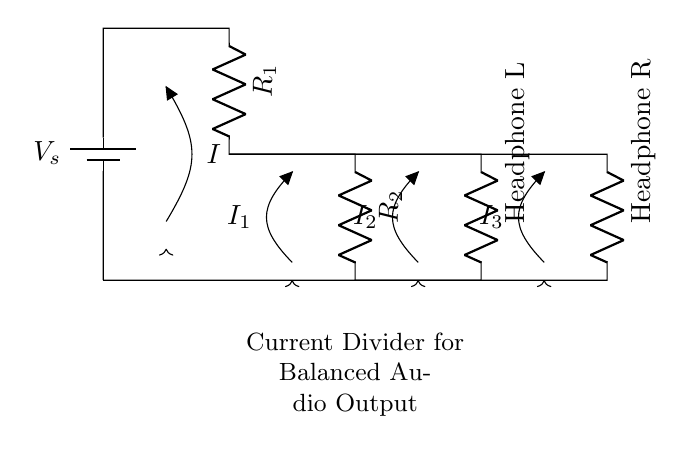What are the resistances in this circuit? The circuit contains two resistors labeled as R1 and R2. The specific values can be inferred from the circuit diagram if indicated, but in this case, they are just presented generically.
Answer: R1, R2 What does the battery represent? The battery symbol labeled V_s represents the voltage source for the circuit, providing the necessary electrical energy to power the audio output.
Answer: V_s What is the purpose of the current divider in this circuit? The current divider is used to split the input current into separate branches, allowing for balanced audio output between the left and right headphones.
Answer: Balanced audio output Which components are connected to the output? The output components are two resistors representing headphones, labeled as Headphone L and Headphone R, connected in parallel to receive the divided current.
Answer: Headphone L, Headphone R How does the total current relate to the branch currents? The total current (I) entering the divider is the sum of the currents through each branch (I1 and I2), thus I equals I1 plus I2 indicating that current is conserved in parallel circuits.
Answer: I = I1 + I2 What would happen if one headphone fails? If one headphone fails (creates an open circuit), the current would only flow through the functioning headphone, resulting in the loss of audio output in one side but maintaining the circuit operational for the other side.
Answer: Loss of audio on one side 